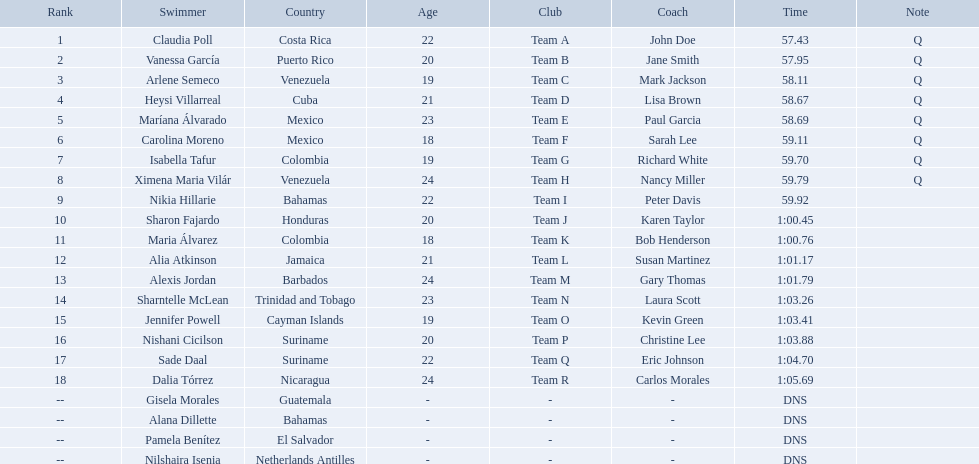Where were the top eight finishers from? Costa Rica, Puerto Rico, Venezuela, Cuba, Mexico, Mexico, Colombia, Venezuela. Which of the top eight were from cuba? Heysi Villarreal. Could you parse the entire table as a dict? {'header': ['Rank', 'Swimmer', 'Country', 'Age', 'Club', 'Coach', 'Time', 'Note'], 'rows': [['1', 'Claudia Poll', 'Costa Rica', '22', 'Team A', 'John Doe', '57.43', 'Q'], ['2', 'Vanessa García', 'Puerto Rico', '20', 'Team B', 'Jane Smith', '57.95', 'Q'], ['3', 'Arlene Semeco', 'Venezuela', '19', 'Team C', 'Mark Jackson', '58.11', 'Q'], ['4', 'Heysi Villarreal', 'Cuba', '21', 'Team D', 'Lisa Brown', '58.67', 'Q'], ['5', 'Maríana Álvarado', 'Mexico', '23', 'Team E', 'Paul Garcia', '58.69', 'Q'], ['6', 'Carolina Moreno', 'Mexico', '18', 'Team F', 'Sarah Lee', '59.11', 'Q'], ['7', 'Isabella Tafur', 'Colombia', '19', 'Team G', 'Richard White', '59.70', 'Q'], ['8', 'Ximena Maria Vilár', 'Venezuela', '24', 'Team H', 'Nancy Miller', '59.79', 'Q'], ['9', 'Nikia Hillarie', 'Bahamas', '22', 'Team I', 'Peter Davis', '59.92', ''], ['10', 'Sharon Fajardo', 'Honduras', '20', 'Team J', 'Karen Taylor', '1:00.45', ''], ['11', 'Maria Álvarez', 'Colombia', '18', 'Team K', 'Bob Henderson', '1:00.76', ''], ['12', 'Alia Atkinson', 'Jamaica', '21', 'Team L', 'Susan Martinez', '1:01.17', ''], ['13', 'Alexis Jordan', 'Barbados', '24', 'Team M', 'Gary Thomas', '1:01.79', ''], ['14', 'Sharntelle McLean', 'Trinidad and Tobago', '23', 'Team N', 'Laura Scott', '1:03.26', ''], ['15', 'Jennifer Powell', 'Cayman Islands', '19', 'Team O', 'Kevin Green', '1:03.41', ''], ['16', 'Nishani Cicilson', 'Suriname', '20', 'Team P', 'Christine Lee', '1:03.88', ''], ['17', 'Sade Daal', 'Suriname', '22', 'Team Q', 'Eric Johnson', '1:04.70', ''], ['18', 'Dalia Tórrez', 'Nicaragua', '24', 'Team R', 'Carlos Morales', '1:05.69', ''], ['--', 'Gisela Morales', 'Guatemala', '-', '-', '-', 'DNS', ''], ['--', 'Alana Dillette', 'Bahamas', '-', '-', '-', 'DNS', ''], ['--', 'Pamela Benítez', 'El Salvador', '-', '-', '-', 'DNS', ''], ['--', 'Nilshaira Isenia', 'Netherlands Antilles', '-', '-', '-', 'DNS', '']]} 